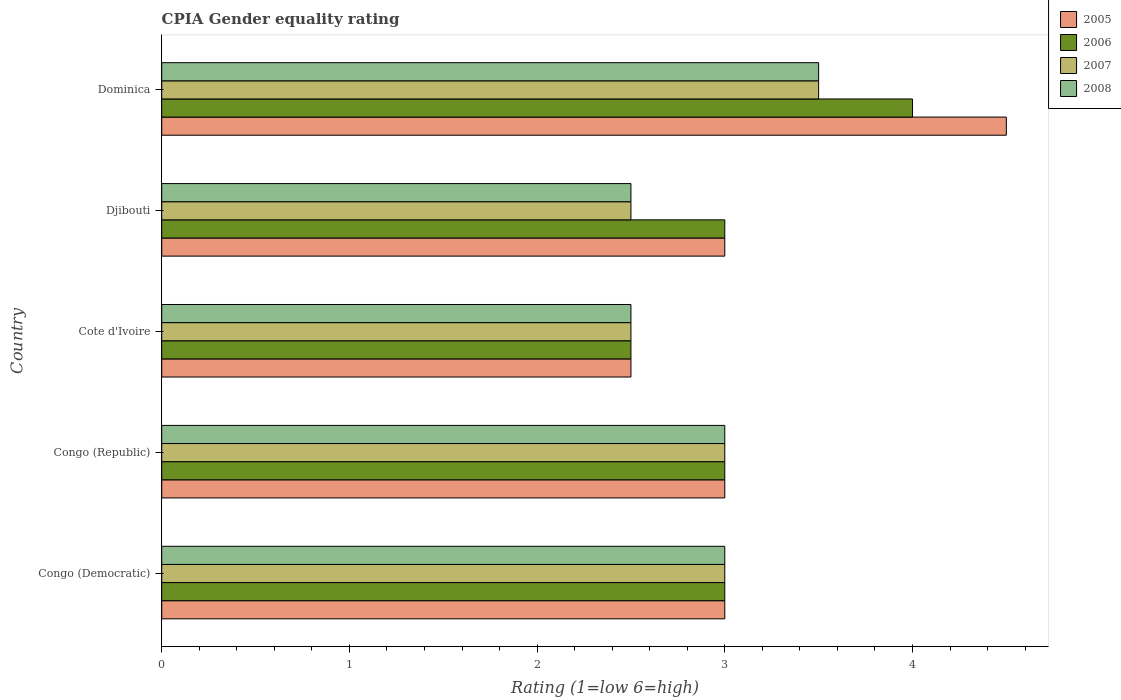How many different coloured bars are there?
Provide a succinct answer. 4. How many groups of bars are there?
Ensure brevity in your answer.  5. Are the number of bars per tick equal to the number of legend labels?
Keep it short and to the point. Yes. How many bars are there on the 5th tick from the top?
Give a very brief answer. 4. How many bars are there on the 5th tick from the bottom?
Your answer should be compact. 4. What is the label of the 3rd group of bars from the top?
Offer a terse response. Cote d'Ivoire. Across all countries, what is the minimum CPIA rating in 2005?
Provide a succinct answer. 2.5. In which country was the CPIA rating in 2007 maximum?
Offer a very short reply. Dominica. In which country was the CPIA rating in 2008 minimum?
Your response must be concise. Cote d'Ivoire. What is the total CPIA rating in 2006 in the graph?
Provide a short and direct response. 15.5. What is the average CPIA rating in 2005 per country?
Offer a very short reply. 3.2. What is the difference between the CPIA rating in 2007 and CPIA rating in 2006 in Congo (Democratic)?
Your answer should be very brief. 0. In how many countries, is the CPIA rating in 2007 greater than 3.8 ?
Ensure brevity in your answer.  0. What is the difference between the highest and the second highest CPIA rating in 2005?
Give a very brief answer. 1.5. What is the difference between the highest and the lowest CPIA rating in 2006?
Your answer should be very brief. 1.5. What does the 3rd bar from the bottom in Djibouti represents?
Provide a short and direct response. 2007. Are all the bars in the graph horizontal?
Offer a very short reply. Yes. What is the difference between two consecutive major ticks on the X-axis?
Offer a very short reply. 1. How many legend labels are there?
Provide a succinct answer. 4. How are the legend labels stacked?
Ensure brevity in your answer.  Vertical. What is the title of the graph?
Keep it short and to the point. CPIA Gender equality rating. Does "1997" appear as one of the legend labels in the graph?
Your answer should be compact. No. What is the label or title of the X-axis?
Keep it short and to the point. Rating (1=low 6=high). What is the label or title of the Y-axis?
Offer a terse response. Country. What is the Rating (1=low 6=high) in 2006 in Congo (Democratic)?
Offer a terse response. 3. What is the Rating (1=low 6=high) of 2008 in Congo (Democratic)?
Keep it short and to the point. 3. What is the Rating (1=low 6=high) in 2007 in Congo (Republic)?
Your answer should be compact. 3. What is the Rating (1=low 6=high) of 2007 in Cote d'Ivoire?
Your answer should be very brief. 2.5. What is the Rating (1=low 6=high) of 2005 in Djibouti?
Provide a short and direct response. 3. What is the Rating (1=low 6=high) of 2006 in Djibouti?
Your answer should be compact. 3. What is the Rating (1=low 6=high) of 2007 in Djibouti?
Provide a succinct answer. 2.5. What is the Rating (1=low 6=high) in 2008 in Djibouti?
Your response must be concise. 2.5. What is the Rating (1=low 6=high) of 2006 in Dominica?
Make the answer very short. 4. What is the Rating (1=low 6=high) in 2007 in Dominica?
Your answer should be compact. 3.5. Across all countries, what is the maximum Rating (1=low 6=high) of 2005?
Your answer should be compact. 4.5. Across all countries, what is the maximum Rating (1=low 6=high) in 2006?
Your response must be concise. 4. Across all countries, what is the maximum Rating (1=low 6=high) in 2008?
Make the answer very short. 3.5. Across all countries, what is the minimum Rating (1=low 6=high) of 2008?
Offer a very short reply. 2.5. What is the total Rating (1=low 6=high) in 2005 in the graph?
Make the answer very short. 16. What is the total Rating (1=low 6=high) of 2007 in the graph?
Offer a terse response. 14.5. What is the total Rating (1=low 6=high) of 2008 in the graph?
Make the answer very short. 14.5. What is the difference between the Rating (1=low 6=high) of 2005 in Congo (Democratic) and that in Cote d'Ivoire?
Your answer should be very brief. 0.5. What is the difference between the Rating (1=low 6=high) in 2006 in Congo (Democratic) and that in Cote d'Ivoire?
Offer a terse response. 0.5. What is the difference between the Rating (1=low 6=high) in 2008 in Congo (Democratic) and that in Djibouti?
Provide a short and direct response. 0.5. What is the difference between the Rating (1=low 6=high) of 2005 in Congo (Democratic) and that in Dominica?
Provide a succinct answer. -1.5. What is the difference between the Rating (1=low 6=high) of 2007 in Congo (Democratic) and that in Dominica?
Your answer should be very brief. -0.5. What is the difference between the Rating (1=low 6=high) in 2007 in Congo (Republic) and that in Cote d'Ivoire?
Give a very brief answer. 0.5. What is the difference between the Rating (1=low 6=high) in 2008 in Congo (Republic) and that in Cote d'Ivoire?
Give a very brief answer. 0.5. What is the difference between the Rating (1=low 6=high) of 2005 in Congo (Republic) and that in Djibouti?
Ensure brevity in your answer.  0. What is the difference between the Rating (1=low 6=high) in 2007 in Congo (Republic) and that in Djibouti?
Provide a short and direct response. 0.5. What is the difference between the Rating (1=low 6=high) in 2008 in Congo (Republic) and that in Djibouti?
Keep it short and to the point. 0.5. What is the difference between the Rating (1=low 6=high) in 2005 in Congo (Republic) and that in Dominica?
Provide a succinct answer. -1.5. What is the difference between the Rating (1=low 6=high) of 2007 in Congo (Republic) and that in Dominica?
Your response must be concise. -0.5. What is the difference between the Rating (1=low 6=high) in 2006 in Cote d'Ivoire and that in Djibouti?
Give a very brief answer. -0.5. What is the difference between the Rating (1=low 6=high) of 2008 in Cote d'Ivoire and that in Djibouti?
Ensure brevity in your answer.  0. What is the difference between the Rating (1=low 6=high) in 2005 in Cote d'Ivoire and that in Dominica?
Provide a short and direct response. -2. What is the difference between the Rating (1=low 6=high) of 2006 in Cote d'Ivoire and that in Dominica?
Your answer should be very brief. -1.5. What is the difference between the Rating (1=low 6=high) in 2007 in Cote d'Ivoire and that in Dominica?
Keep it short and to the point. -1. What is the difference between the Rating (1=low 6=high) in 2008 in Cote d'Ivoire and that in Dominica?
Give a very brief answer. -1. What is the difference between the Rating (1=low 6=high) of 2008 in Djibouti and that in Dominica?
Give a very brief answer. -1. What is the difference between the Rating (1=low 6=high) of 2005 in Congo (Democratic) and the Rating (1=low 6=high) of 2006 in Congo (Republic)?
Provide a succinct answer. 0. What is the difference between the Rating (1=low 6=high) in 2005 in Congo (Democratic) and the Rating (1=low 6=high) in 2007 in Congo (Republic)?
Make the answer very short. 0. What is the difference between the Rating (1=low 6=high) of 2005 in Congo (Democratic) and the Rating (1=low 6=high) of 2008 in Congo (Republic)?
Your response must be concise. 0. What is the difference between the Rating (1=low 6=high) in 2006 in Congo (Democratic) and the Rating (1=low 6=high) in 2007 in Congo (Republic)?
Ensure brevity in your answer.  0. What is the difference between the Rating (1=low 6=high) in 2007 in Congo (Democratic) and the Rating (1=low 6=high) in 2008 in Congo (Republic)?
Ensure brevity in your answer.  0. What is the difference between the Rating (1=low 6=high) of 2005 in Congo (Democratic) and the Rating (1=low 6=high) of 2006 in Cote d'Ivoire?
Make the answer very short. 0.5. What is the difference between the Rating (1=low 6=high) of 2005 in Congo (Democratic) and the Rating (1=low 6=high) of 2007 in Cote d'Ivoire?
Your response must be concise. 0.5. What is the difference between the Rating (1=low 6=high) of 2005 in Congo (Democratic) and the Rating (1=low 6=high) of 2008 in Cote d'Ivoire?
Make the answer very short. 0.5. What is the difference between the Rating (1=low 6=high) in 2006 in Congo (Democratic) and the Rating (1=low 6=high) in 2007 in Cote d'Ivoire?
Your response must be concise. 0.5. What is the difference between the Rating (1=low 6=high) of 2007 in Congo (Democratic) and the Rating (1=low 6=high) of 2008 in Cote d'Ivoire?
Offer a very short reply. 0.5. What is the difference between the Rating (1=low 6=high) in 2006 in Congo (Democratic) and the Rating (1=low 6=high) in 2007 in Djibouti?
Provide a succinct answer. 0.5. What is the difference between the Rating (1=low 6=high) in 2006 in Congo (Democratic) and the Rating (1=low 6=high) in 2008 in Djibouti?
Keep it short and to the point. 0.5. What is the difference between the Rating (1=low 6=high) of 2007 in Congo (Democratic) and the Rating (1=low 6=high) of 2008 in Djibouti?
Keep it short and to the point. 0.5. What is the difference between the Rating (1=low 6=high) of 2006 in Congo (Democratic) and the Rating (1=low 6=high) of 2008 in Dominica?
Provide a short and direct response. -0.5. What is the difference between the Rating (1=low 6=high) of 2005 in Congo (Republic) and the Rating (1=low 6=high) of 2006 in Cote d'Ivoire?
Your answer should be very brief. 0.5. What is the difference between the Rating (1=low 6=high) in 2005 in Congo (Republic) and the Rating (1=low 6=high) in 2007 in Cote d'Ivoire?
Make the answer very short. 0.5. What is the difference between the Rating (1=low 6=high) of 2006 in Congo (Republic) and the Rating (1=low 6=high) of 2008 in Cote d'Ivoire?
Keep it short and to the point. 0.5. What is the difference between the Rating (1=low 6=high) in 2005 in Congo (Republic) and the Rating (1=low 6=high) in 2006 in Djibouti?
Your answer should be compact. 0. What is the difference between the Rating (1=low 6=high) in 2005 in Congo (Republic) and the Rating (1=low 6=high) in 2007 in Djibouti?
Make the answer very short. 0.5. What is the difference between the Rating (1=low 6=high) of 2005 in Congo (Republic) and the Rating (1=low 6=high) of 2008 in Djibouti?
Your response must be concise. 0.5. What is the difference between the Rating (1=low 6=high) in 2007 in Congo (Republic) and the Rating (1=low 6=high) in 2008 in Djibouti?
Provide a short and direct response. 0.5. What is the difference between the Rating (1=low 6=high) of 2005 in Congo (Republic) and the Rating (1=low 6=high) of 2008 in Dominica?
Offer a terse response. -0.5. What is the difference between the Rating (1=low 6=high) in 2006 in Congo (Republic) and the Rating (1=low 6=high) in 2008 in Dominica?
Offer a terse response. -0.5. What is the difference between the Rating (1=low 6=high) in 2005 in Cote d'Ivoire and the Rating (1=low 6=high) in 2006 in Djibouti?
Provide a succinct answer. -0.5. What is the difference between the Rating (1=low 6=high) of 2005 in Cote d'Ivoire and the Rating (1=low 6=high) of 2007 in Djibouti?
Provide a short and direct response. 0. What is the difference between the Rating (1=low 6=high) in 2006 in Cote d'Ivoire and the Rating (1=low 6=high) in 2007 in Djibouti?
Offer a very short reply. 0. What is the difference between the Rating (1=low 6=high) in 2005 in Cote d'Ivoire and the Rating (1=low 6=high) in 2008 in Dominica?
Keep it short and to the point. -1. What is the difference between the Rating (1=low 6=high) in 2006 in Cote d'Ivoire and the Rating (1=low 6=high) in 2008 in Dominica?
Provide a short and direct response. -1. What is the difference between the Rating (1=low 6=high) in 2005 in Djibouti and the Rating (1=low 6=high) in 2006 in Dominica?
Provide a succinct answer. -1. What is the difference between the Rating (1=low 6=high) in 2005 in Djibouti and the Rating (1=low 6=high) in 2007 in Dominica?
Your answer should be very brief. -0.5. What is the difference between the Rating (1=low 6=high) of 2005 in Djibouti and the Rating (1=low 6=high) of 2008 in Dominica?
Give a very brief answer. -0.5. What is the difference between the Rating (1=low 6=high) in 2006 in Djibouti and the Rating (1=low 6=high) in 2008 in Dominica?
Your answer should be very brief. -0.5. What is the average Rating (1=low 6=high) of 2005 per country?
Make the answer very short. 3.2. What is the average Rating (1=low 6=high) in 2006 per country?
Offer a terse response. 3.1. What is the average Rating (1=low 6=high) of 2007 per country?
Ensure brevity in your answer.  2.9. What is the difference between the Rating (1=low 6=high) in 2005 and Rating (1=low 6=high) in 2006 in Congo (Democratic)?
Keep it short and to the point. 0. What is the difference between the Rating (1=low 6=high) in 2005 and Rating (1=low 6=high) in 2007 in Congo (Democratic)?
Your answer should be very brief. 0. What is the difference between the Rating (1=low 6=high) of 2005 and Rating (1=low 6=high) of 2008 in Congo (Democratic)?
Your response must be concise. 0. What is the difference between the Rating (1=low 6=high) in 2005 and Rating (1=low 6=high) in 2007 in Congo (Republic)?
Your answer should be very brief. 0. What is the difference between the Rating (1=low 6=high) of 2006 and Rating (1=low 6=high) of 2007 in Congo (Republic)?
Your answer should be compact. 0. What is the difference between the Rating (1=low 6=high) in 2005 and Rating (1=low 6=high) in 2007 in Cote d'Ivoire?
Give a very brief answer. 0. What is the difference between the Rating (1=low 6=high) of 2005 and Rating (1=low 6=high) of 2008 in Cote d'Ivoire?
Offer a very short reply. 0. What is the difference between the Rating (1=low 6=high) of 2006 and Rating (1=low 6=high) of 2008 in Cote d'Ivoire?
Ensure brevity in your answer.  0. What is the difference between the Rating (1=low 6=high) in 2006 and Rating (1=low 6=high) in 2007 in Djibouti?
Provide a succinct answer. 0.5. What is the difference between the Rating (1=low 6=high) in 2006 and Rating (1=low 6=high) in 2008 in Djibouti?
Provide a short and direct response. 0.5. What is the difference between the Rating (1=low 6=high) in 2005 and Rating (1=low 6=high) in 2008 in Dominica?
Offer a very short reply. 1. What is the difference between the Rating (1=low 6=high) in 2006 and Rating (1=low 6=high) in 2007 in Dominica?
Provide a short and direct response. 0.5. What is the difference between the Rating (1=low 6=high) in 2007 and Rating (1=low 6=high) in 2008 in Dominica?
Your answer should be compact. 0. What is the ratio of the Rating (1=low 6=high) of 2006 in Congo (Democratic) to that in Congo (Republic)?
Your response must be concise. 1. What is the ratio of the Rating (1=low 6=high) in 2007 in Congo (Democratic) to that in Cote d'Ivoire?
Offer a terse response. 1.2. What is the ratio of the Rating (1=low 6=high) of 2008 in Congo (Democratic) to that in Cote d'Ivoire?
Ensure brevity in your answer.  1.2. What is the ratio of the Rating (1=low 6=high) of 2006 in Congo (Democratic) to that in Dominica?
Ensure brevity in your answer.  0.75. What is the ratio of the Rating (1=low 6=high) in 2005 in Congo (Republic) to that in Cote d'Ivoire?
Make the answer very short. 1.2. What is the ratio of the Rating (1=low 6=high) in 2006 in Congo (Republic) to that in Cote d'Ivoire?
Give a very brief answer. 1.2. What is the ratio of the Rating (1=low 6=high) of 2007 in Congo (Republic) to that in Cote d'Ivoire?
Keep it short and to the point. 1.2. What is the ratio of the Rating (1=low 6=high) of 2005 in Congo (Republic) to that in Djibouti?
Your response must be concise. 1. What is the ratio of the Rating (1=low 6=high) in 2007 in Congo (Republic) to that in Djibouti?
Make the answer very short. 1.2. What is the ratio of the Rating (1=low 6=high) in 2007 in Congo (Republic) to that in Dominica?
Give a very brief answer. 0.86. What is the ratio of the Rating (1=low 6=high) of 2005 in Cote d'Ivoire to that in Djibouti?
Offer a very short reply. 0.83. What is the ratio of the Rating (1=low 6=high) in 2008 in Cote d'Ivoire to that in Djibouti?
Offer a very short reply. 1. What is the ratio of the Rating (1=low 6=high) of 2005 in Cote d'Ivoire to that in Dominica?
Make the answer very short. 0.56. What is the ratio of the Rating (1=low 6=high) in 2008 in Cote d'Ivoire to that in Dominica?
Offer a very short reply. 0.71. What is the ratio of the Rating (1=low 6=high) of 2005 in Djibouti to that in Dominica?
Provide a succinct answer. 0.67. What is the ratio of the Rating (1=low 6=high) in 2008 in Djibouti to that in Dominica?
Offer a very short reply. 0.71. What is the difference between the highest and the second highest Rating (1=low 6=high) of 2005?
Give a very brief answer. 1.5. What is the difference between the highest and the second highest Rating (1=low 6=high) in 2006?
Make the answer very short. 1. What is the difference between the highest and the second highest Rating (1=low 6=high) of 2007?
Provide a succinct answer. 0.5. What is the difference between the highest and the second highest Rating (1=low 6=high) of 2008?
Ensure brevity in your answer.  0.5. What is the difference between the highest and the lowest Rating (1=low 6=high) of 2005?
Keep it short and to the point. 2. What is the difference between the highest and the lowest Rating (1=low 6=high) of 2006?
Your response must be concise. 1.5. What is the difference between the highest and the lowest Rating (1=low 6=high) of 2007?
Offer a terse response. 1. 